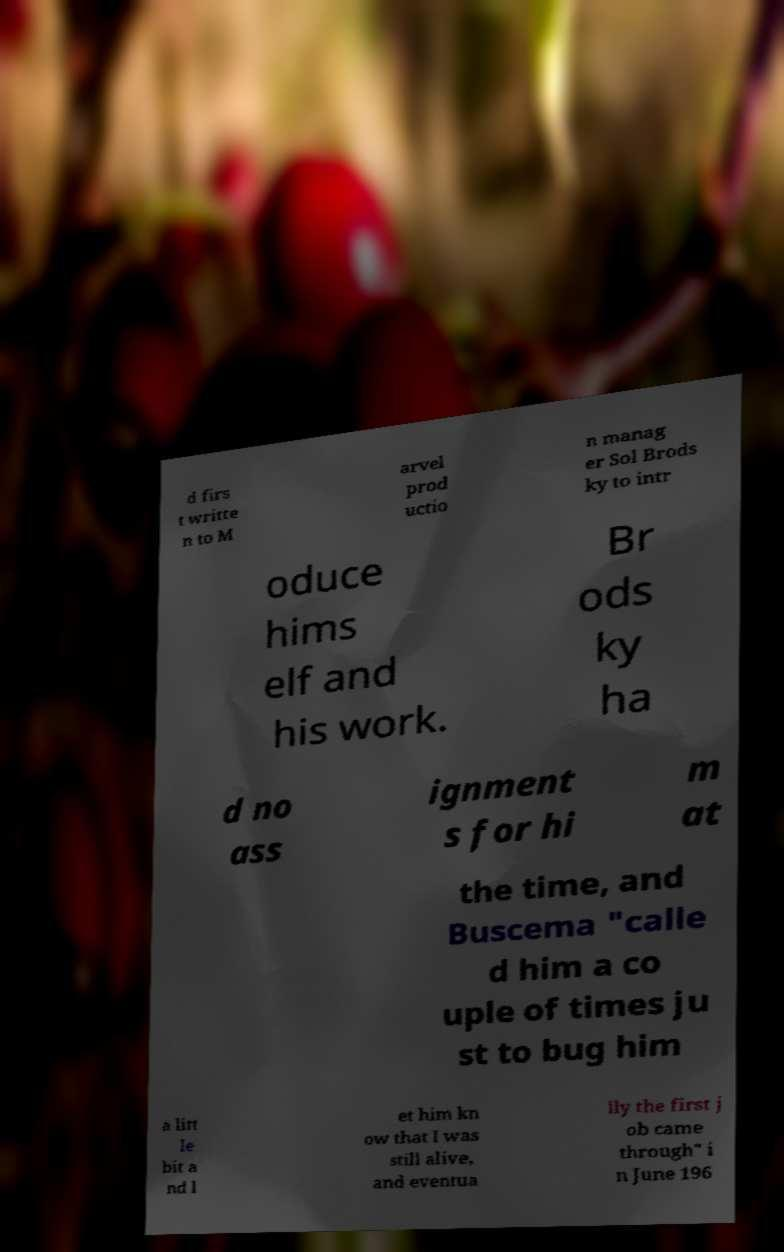Please identify and transcribe the text found in this image. d firs t writte n to M arvel prod uctio n manag er Sol Brods ky to intr oduce hims elf and his work. Br ods ky ha d no ass ignment s for hi m at the time, and Buscema "calle d him a co uple of times ju st to bug him a litt le bit a nd l et him kn ow that I was still alive, and eventua lly the first j ob came through" i n June 196 